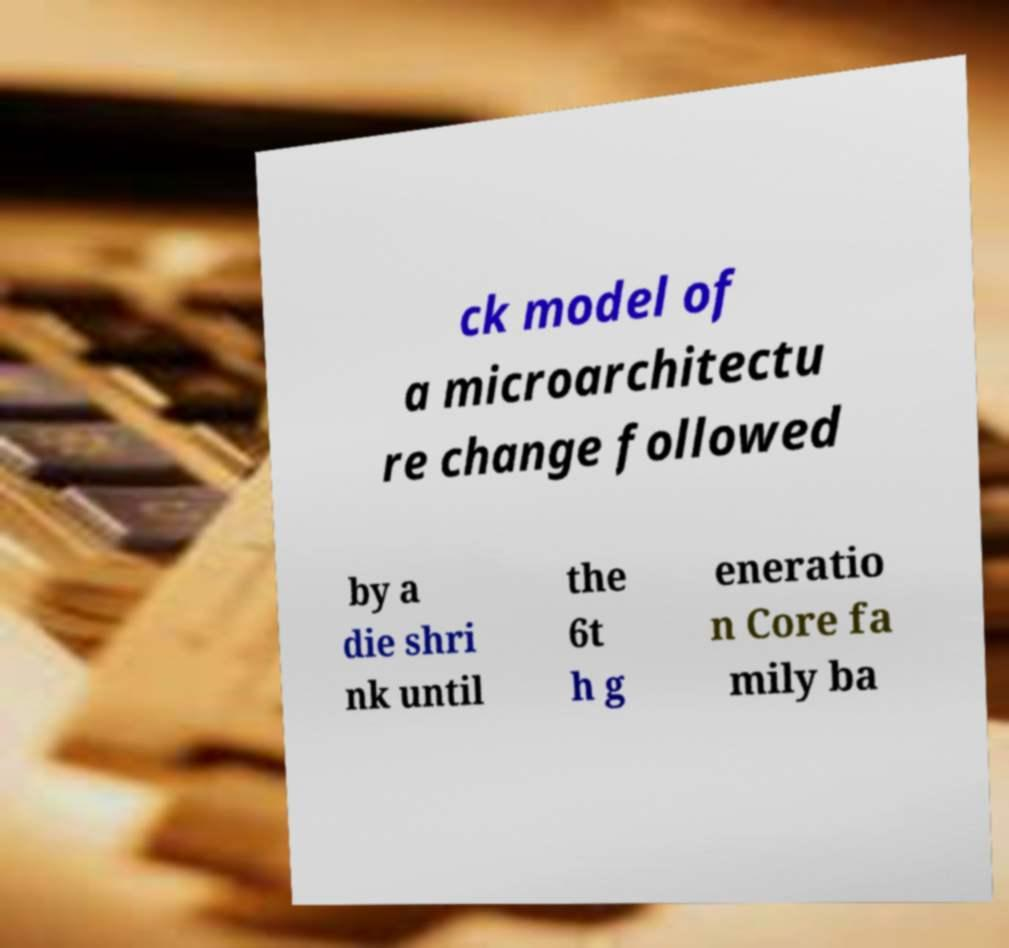Please identify and transcribe the text found in this image. ck model of a microarchitectu re change followed by a die shri nk until the 6t h g eneratio n Core fa mily ba 